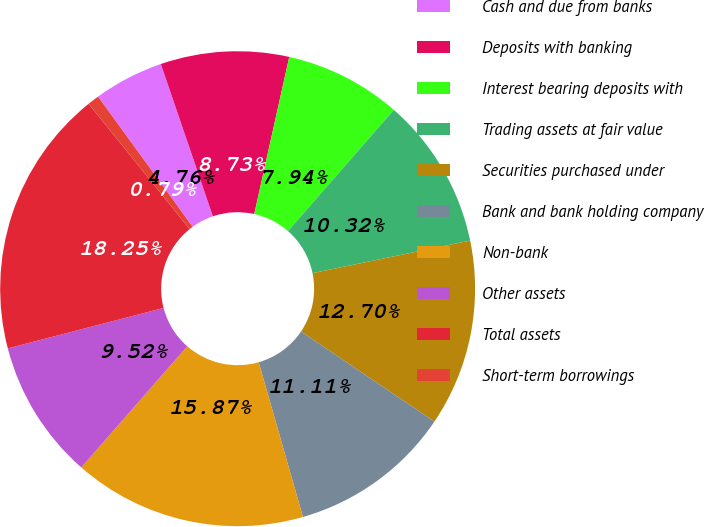Convert chart to OTSL. <chart><loc_0><loc_0><loc_500><loc_500><pie_chart><fcel>Cash and due from banks<fcel>Deposits with banking<fcel>Interest bearing deposits with<fcel>Trading assets at fair value<fcel>Securities purchased under<fcel>Bank and bank holding company<fcel>Non-bank<fcel>Other assets<fcel>Total assets<fcel>Short-term borrowings<nl><fcel>4.76%<fcel>8.73%<fcel>7.94%<fcel>10.32%<fcel>12.7%<fcel>11.11%<fcel>15.87%<fcel>9.52%<fcel>18.25%<fcel>0.79%<nl></chart> 